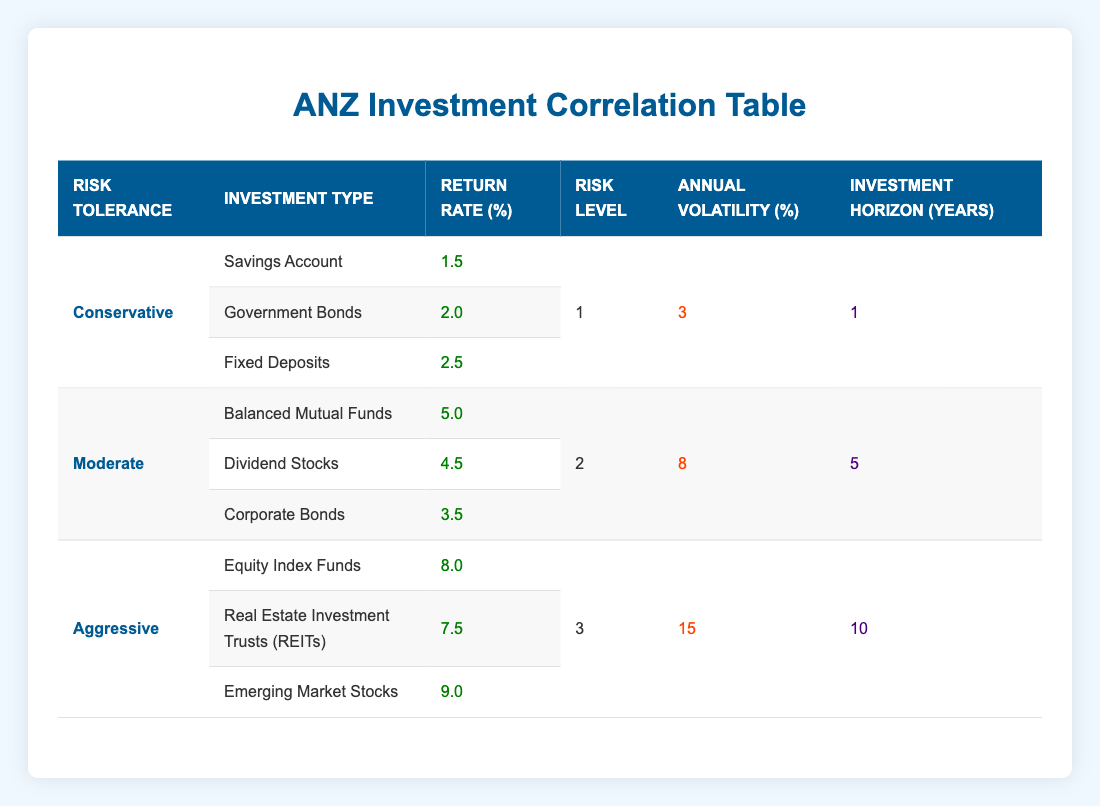What is the return rate for Savings Accounts under Conservative risk tolerance? The table shows that the return rate for Savings Accounts is listed directly under the Conservative risk tolerance level, which is 1.5%.
Answer: 1.5% What is the highest investment return rate among all investment types? From the data provided in the table, Emerging Market Stocks has the highest return rate at 9.0%.
Answer: 9.0% Are Government Bonds categorized under Moderate risk tolerance? Looking at the table, Government Bonds are listed under Conservative risk tolerance, not Moderate. Therefore, the answer is no.
Answer: No What is the annual volatility for Aggressive investments? The table indicates that the annual volatility for Aggressive investments is listed as 15%.
Answer: 15% If I invest in Balanced Mutual Funds, how much annual return can I expect? The return rate for Balanced Mutual Funds, found in the Moderate risk tolerance section of the table, is 5.0%.
Answer: 5.0% What is the total return rate from the Conservative investments? To find the total return rate for Conservative investments, combine the return rates: 1.5% (Savings Account) + 2.0% (Government Bonds) + 2.5% (Fixed Deposits) = 6.0%.
Answer: 6.0% Does the Aggressive investment category have a longer investment horizon than the Conservative category? The investment horizon for Aggressive investments is 10 years while for Conservative it is 1 year. Since 10 is greater than 1, the answer is yes.
Answer: Yes What is the average return rate of investments under Moderate risk tolerance? To find the average return rate under Moderate risk tolerance, add the return rates of Balanced Mutual Funds (5.0%), Dividend Stocks (4.5%), and Corporate Bonds (3.5%) which equals 13.0%. Then, divide by 3 (the number of investment types), resulting in an average return rate of 13.0% / 3 = 4.33%.
Answer: 4.33% Are the risk levels for Conservative and Moderate investments the same? The risk level for Conservative investments is 1 and for Moderate investments, it is 2. Since these values are different, the answer is no.
Answer: No 